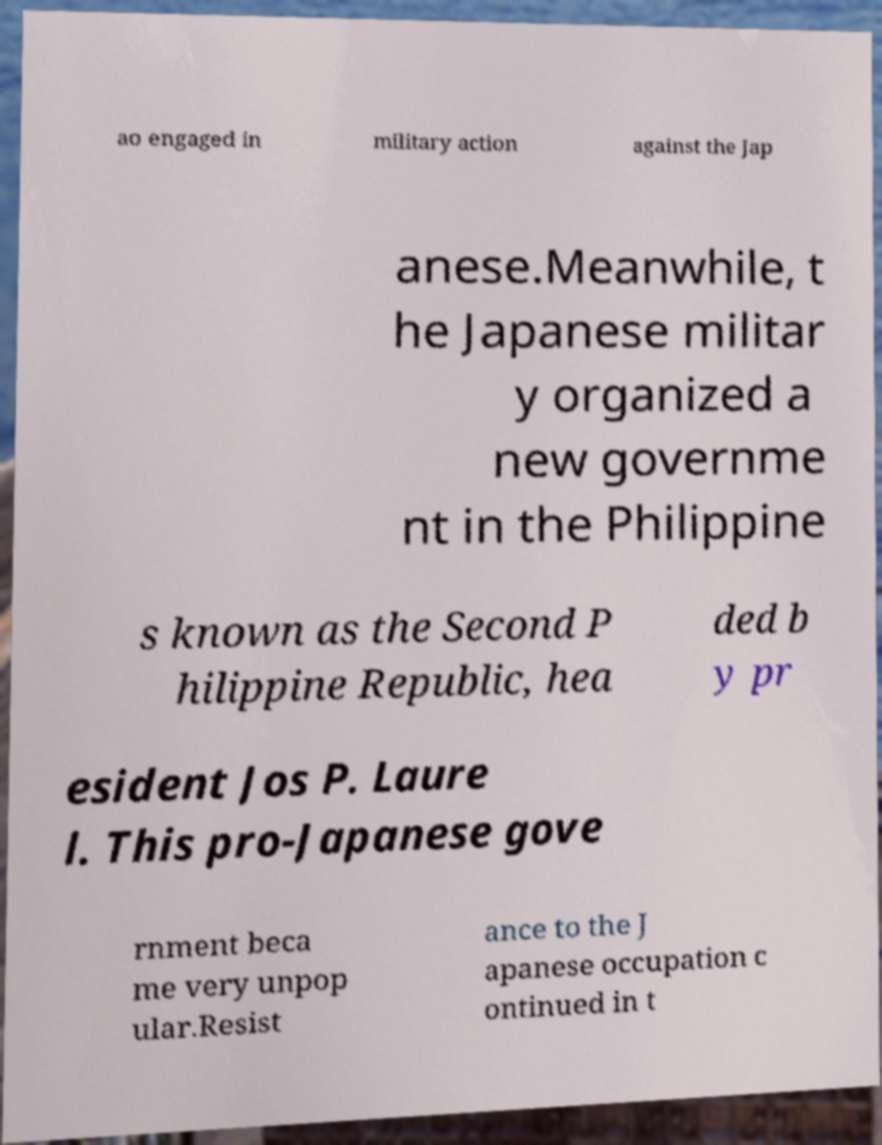What messages or text are displayed in this image? I need them in a readable, typed format. ao engaged in military action against the Jap anese.Meanwhile, t he Japanese militar y organized a new governme nt in the Philippine s known as the Second P hilippine Republic, hea ded b y pr esident Jos P. Laure l. This pro-Japanese gove rnment beca me very unpop ular.Resist ance to the J apanese occupation c ontinued in t 